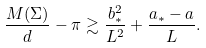<formula> <loc_0><loc_0><loc_500><loc_500>\frac { M ( \Sigma ) } { d } - \pi \gtrsim \frac { b _ { * } ^ { 2 } } { L ^ { 2 } } + \frac { a _ { * } - a } { L } .</formula> 